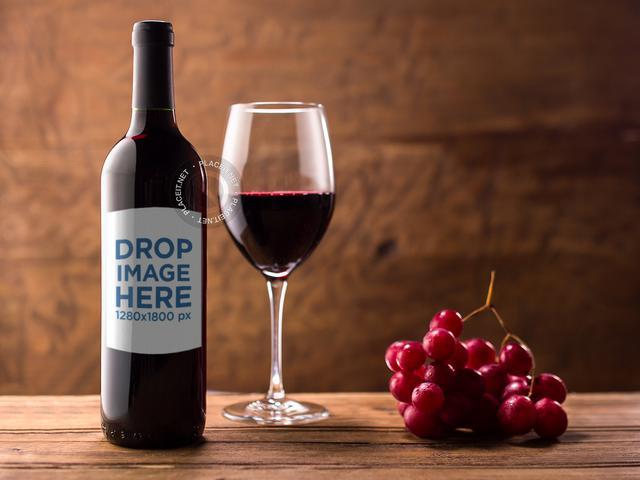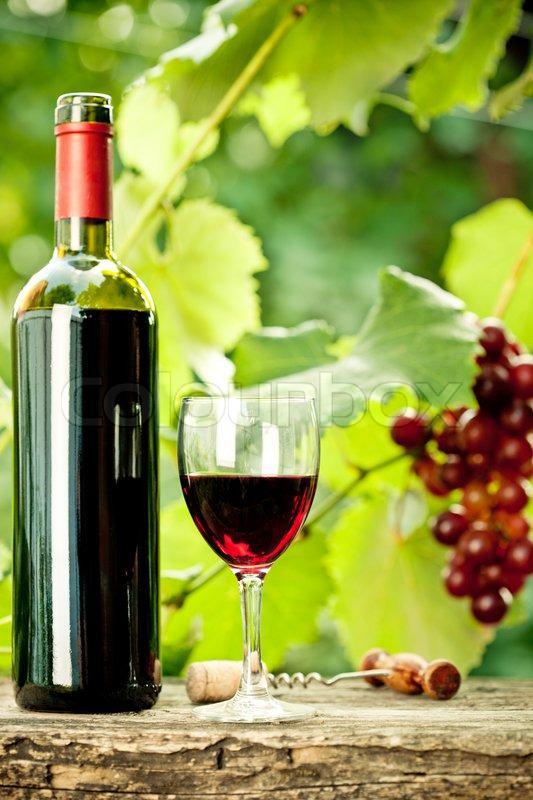The first image is the image on the left, the second image is the image on the right. Considering the images on both sides, is "there is exactly one bottle in the image on the right" valid? Answer yes or no. Yes. The first image is the image on the left, the second image is the image on the right. For the images displayed, is the sentence "An image shows wine bottle, glass, grapes and green leaves." factually correct? Answer yes or no. Yes. 